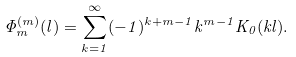Convert formula to latex. <formula><loc_0><loc_0><loc_500><loc_500>\Phi _ { m } ^ { ( m ) } ( l ) = \sum _ { k = 1 } ^ { \infty } ( - 1 ) ^ { k + m - 1 } k ^ { m - 1 } K _ { 0 } ( k l ) .</formula> 